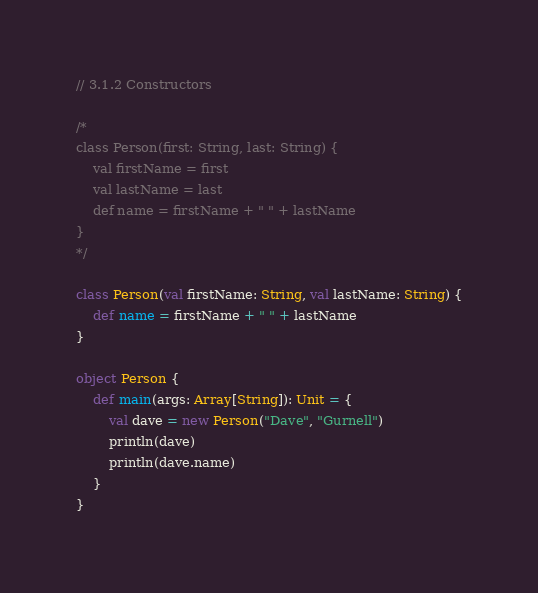<code> <loc_0><loc_0><loc_500><loc_500><_Scala_>// 3.1.2 Constructors

/*
class Person(first: String, last: String) {
    val firstName = first
    val lastName = last
    def name = firstName + " " + lastName
}
*/

class Person(val firstName: String, val lastName: String) {
    def name = firstName + " " + lastName
}

object Person {
    def main(args: Array[String]): Unit = {
        val dave = new Person("Dave", "Gurnell")
        println(dave)
        println(dave.name)
    }
}</code> 